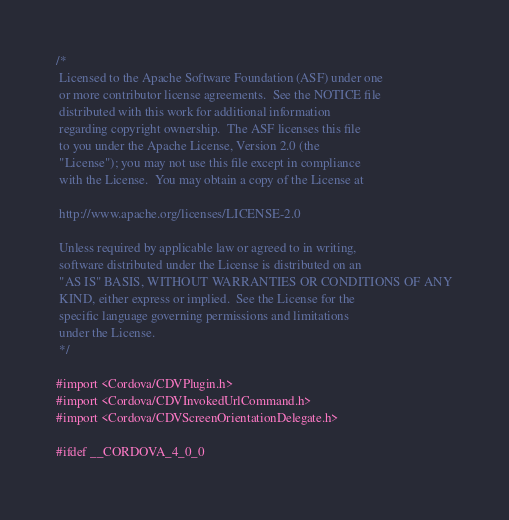<code> <loc_0><loc_0><loc_500><loc_500><_C_>/*
 Licensed to the Apache Software Foundation (ASF) under one
 or more contributor license agreements.  See the NOTICE file
 distributed with this work for additional information
 regarding copyright ownership.  The ASF licenses this file
 to you under the Apache License, Version 2.0 (the
 "License"); you may not use this file except in compliance
 with the License.  You may obtain a copy of the License at
 
 http://www.apache.org/licenses/LICENSE-2.0
 
 Unless required by applicable law or agreed to in writing,
 software distributed under the License is distributed on an
 "AS IS" BASIS, WITHOUT WARRANTIES OR CONDITIONS OF ANY
 KIND, either express or implied.  See the License for the
 specific language governing permissions and limitations
 under the License.
 */

#import <Cordova/CDVPlugin.h>
#import <Cordova/CDVInvokedUrlCommand.h>
#import <Cordova/CDVScreenOrientationDelegate.h>

#ifdef __CORDOVA_4_0_0</code> 